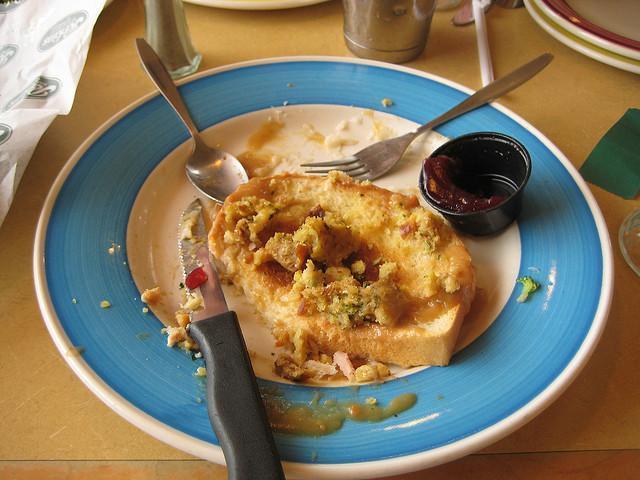How many cups can you see?
Give a very brief answer. 2. 